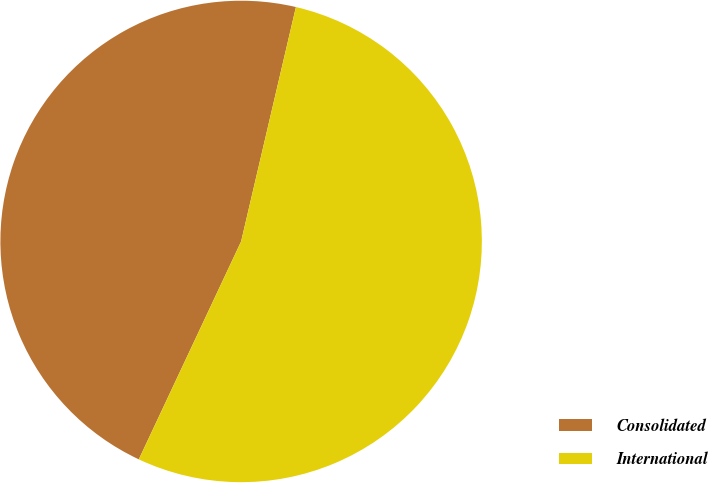<chart> <loc_0><loc_0><loc_500><loc_500><pie_chart><fcel>Consolidated<fcel>International<nl><fcel>46.67%<fcel>53.33%<nl></chart> 